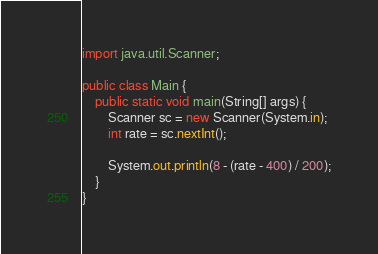Convert code to text. <code><loc_0><loc_0><loc_500><loc_500><_Java_>import java.util.Scanner;

public class Main {
    public static void main(String[] args) {
        Scanner sc = new Scanner(System.in);
        int rate = sc.nextInt();

        System.out.println(8 - (rate - 400) / 200);
    }
}
</code> 